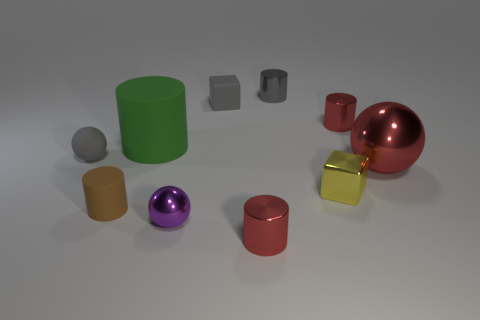What number of matte blocks have the same color as the small matte sphere?
Provide a short and direct response. 1. There is a yellow object that is made of the same material as the large red thing; what shape is it?
Give a very brief answer. Cube. There is a metal ball that is in front of the large red metal thing; what size is it?
Ensure brevity in your answer.  Small. Is the number of tiny gray cubes in front of the small rubber block the same as the number of green matte cylinders that are right of the tiny yellow object?
Give a very brief answer. Yes. There is a small matte cylinder that is in front of the red shiny object that is on the right side of the red object behind the big green matte object; what color is it?
Provide a short and direct response. Brown. How many tiny rubber things are on the right side of the big green thing and in front of the tiny yellow metallic object?
Ensure brevity in your answer.  0. Is the color of the tiny shiny cylinder that is in front of the brown thing the same as the tiny matte object in front of the gray ball?
Your response must be concise. No. Are there any other things that are made of the same material as the gray ball?
Your answer should be compact. Yes. What size is the gray metallic object that is the same shape as the large green thing?
Provide a succinct answer. Small. Are there any small metallic spheres on the right side of the metal cube?
Your response must be concise. No. 